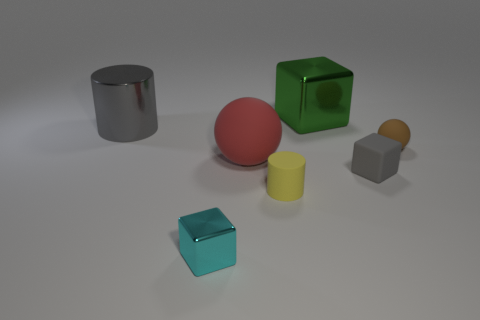Add 2 big red objects. How many objects exist? 9 Subtract all blocks. How many objects are left? 4 Add 5 gray rubber objects. How many gray rubber objects are left? 6 Add 3 tiny gray objects. How many tiny gray objects exist? 4 Subtract 0 green balls. How many objects are left? 7 Subtract all tiny matte things. Subtract all small gray matte things. How many objects are left? 3 